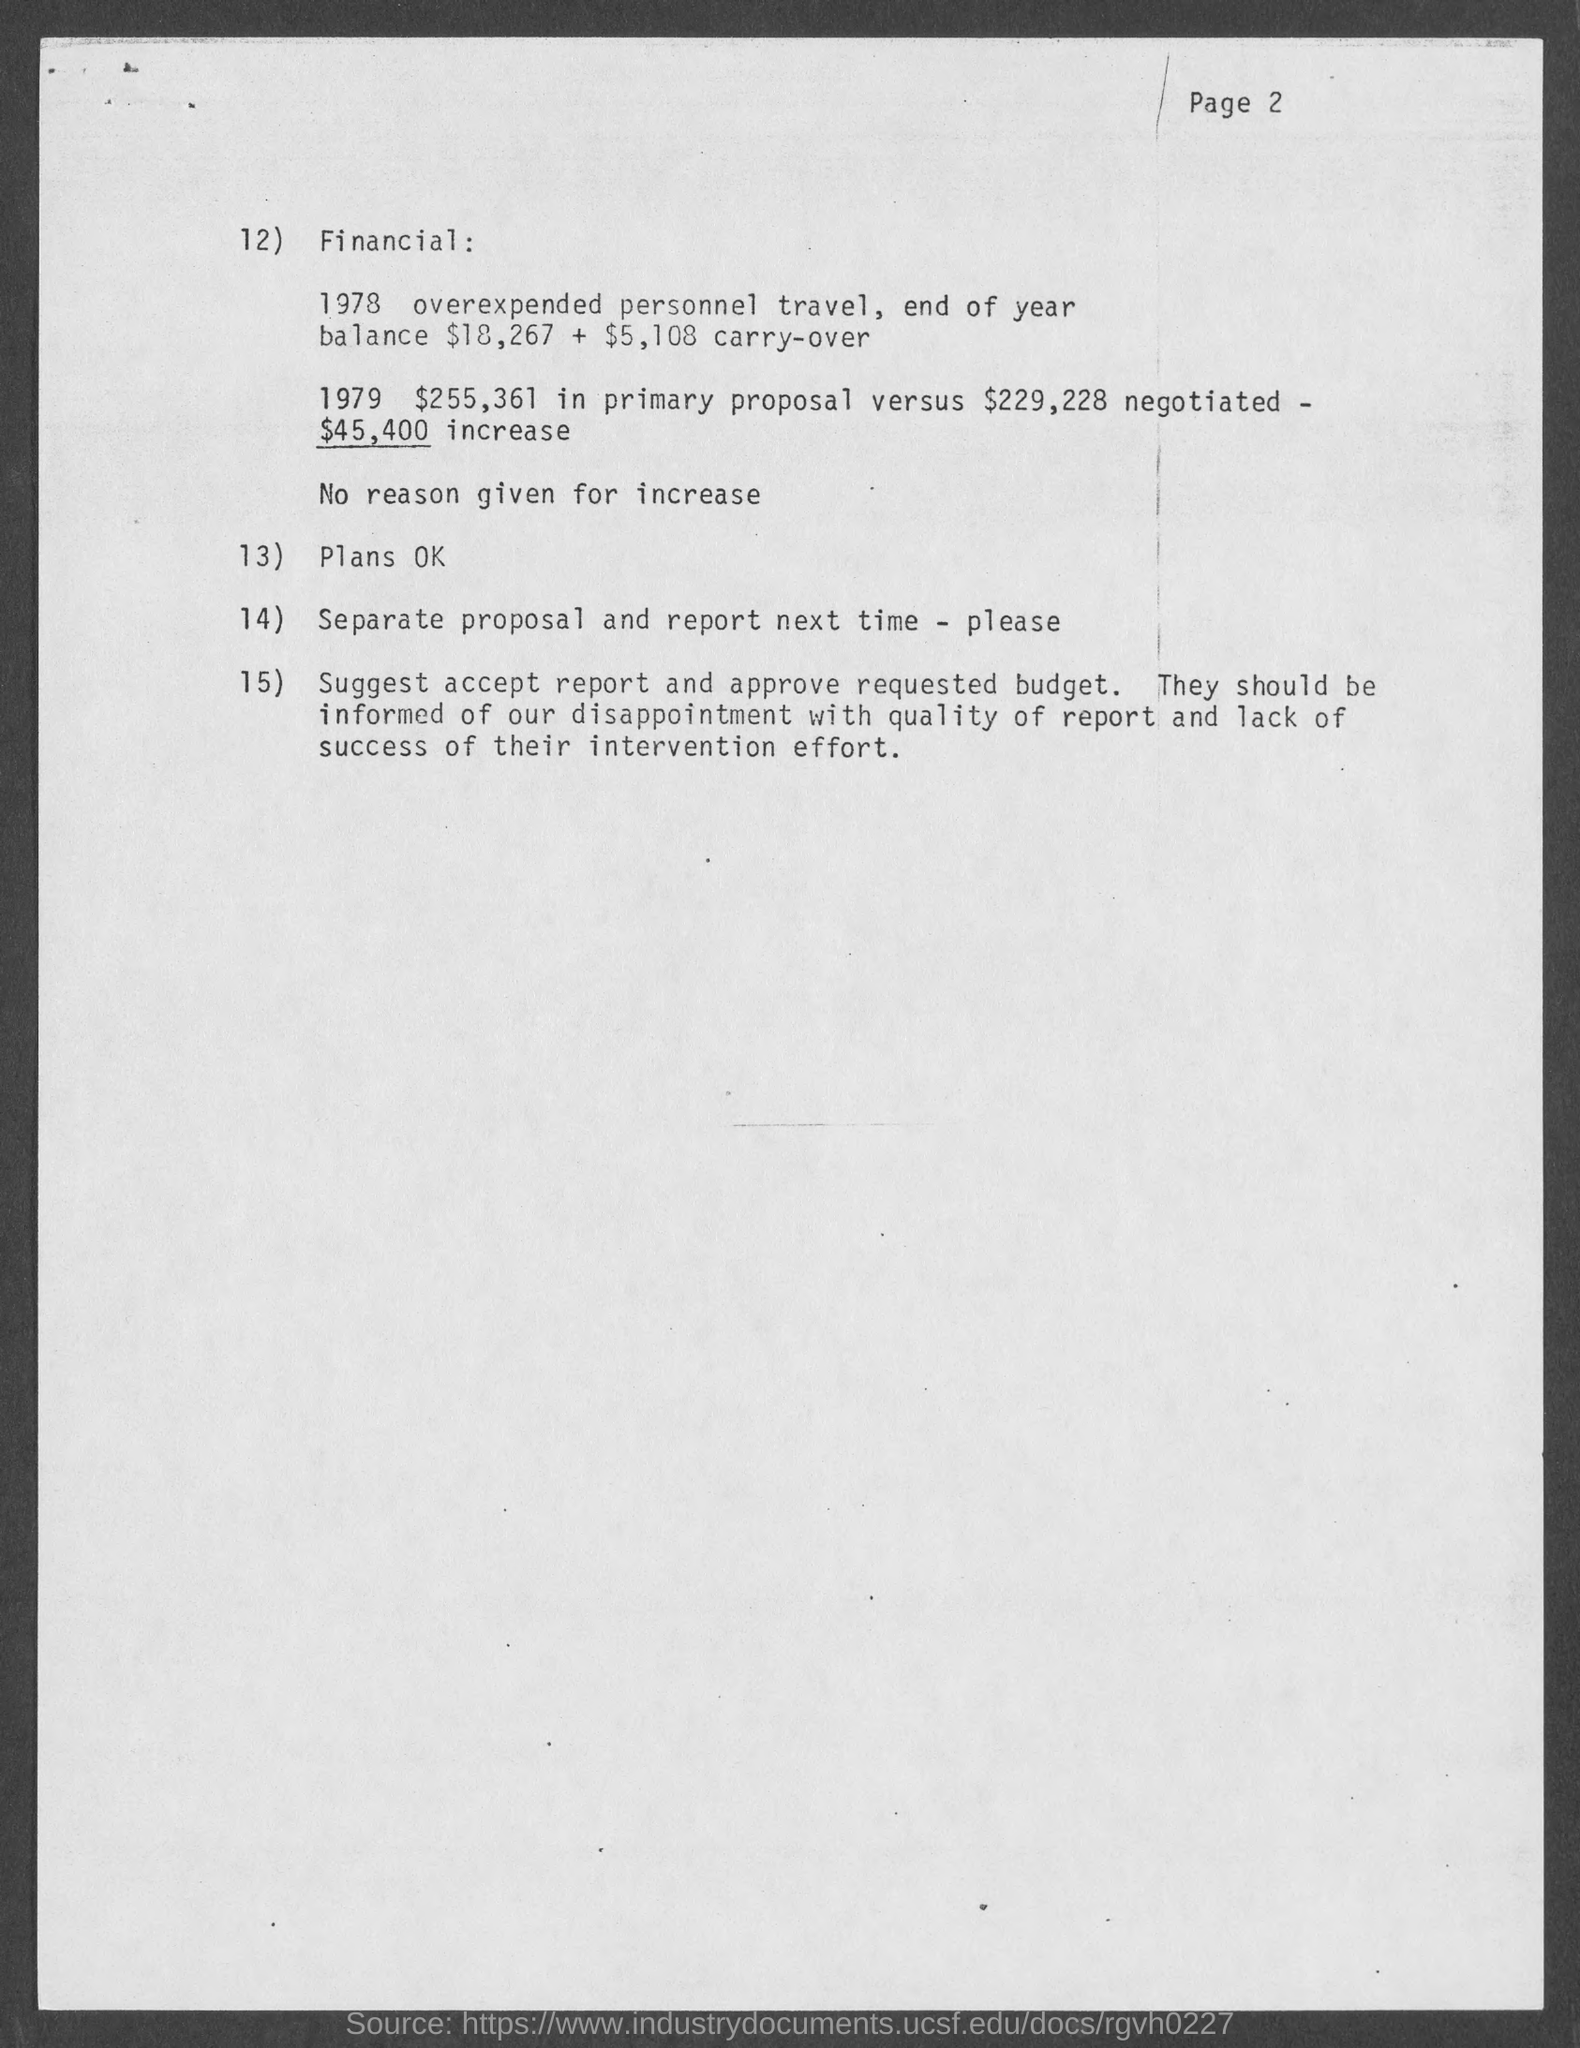List a handful of essential elements in this visual. The page number at the top of the page is 2 and it is declared. 